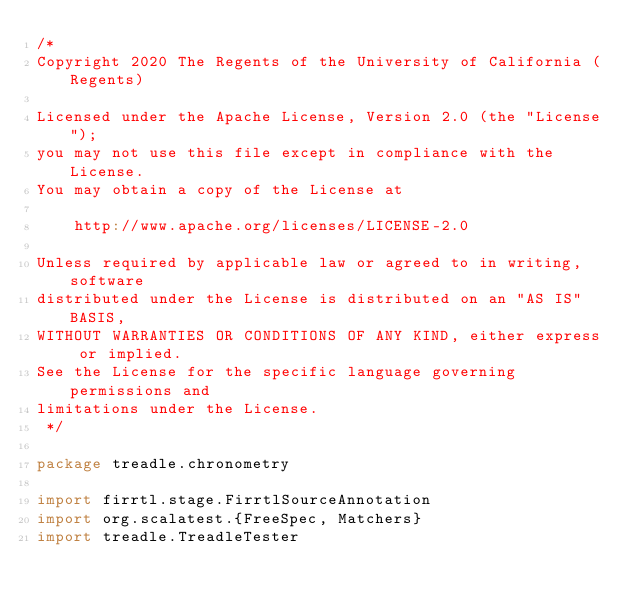Convert code to text. <code><loc_0><loc_0><loc_500><loc_500><_Scala_>/*
Copyright 2020 The Regents of the University of California (Regents)

Licensed under the Apache License, Version 2.0 (the "License");
you may not use this file except in compliance with the License.
You may obtain a copy of the License at

    http://www.apache.org/licenses/LICENSE-2.0

Unless required by applicable law or agreed to in writing, software
distributed under the License is distributed on an "AS IS" BASIS,
WITHOUT WARRANTIES OR CONDITIONS OF ANY KIND, either express or implied.
See the License for the specific language governing permissions and
limitations under the License.
 */

package treadle.chronometry

import firrtl.stage.FirrtlSourceAnnotation
import org.scalatest.{FreeSpec, Matchers}
import treadle.TreadleTester
</code> 